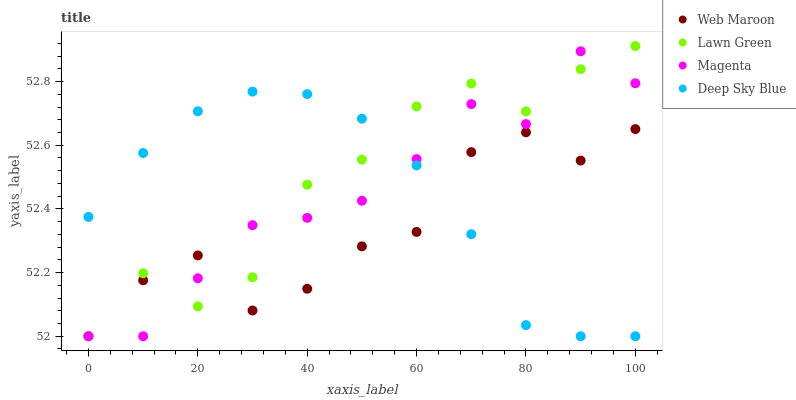Does Web Maroon have the minimum area under the curve?
Answer yes or no. Yes. Does Lawn Green have the maximum area under the curve?
Answer yes or no. Yes. Does Magenta have the minimum area under the curve?
Answer yes or no. No. Does Magenta have the maximum area under the curve?
Answer yes or no. No. Is Deep Sky Blue the smoothest?
Answer yes or no. Yes. Is Lawn Green the roughest?
Answer yes or no. Yes. Is Magenta the smoothest?
Answer yes or no. No. Is Magenta the roughest?
Answer yes or no. No. Does Lawn Green have the lowest value?
Answer yes or no. Yes. Does Lawn Green have the highest value?
Answer yes or no. Yes. Does Magenta have the highest value?
Answer yes or no. No. Does Lawn Green intersect Web Maroon?
Answer yes or no. Yes. Is Lawn Green less than Web Maroon?
Answer yes or no. No. Is Lawn Green greater than Web Maroon?
Answer yes or no. No. 